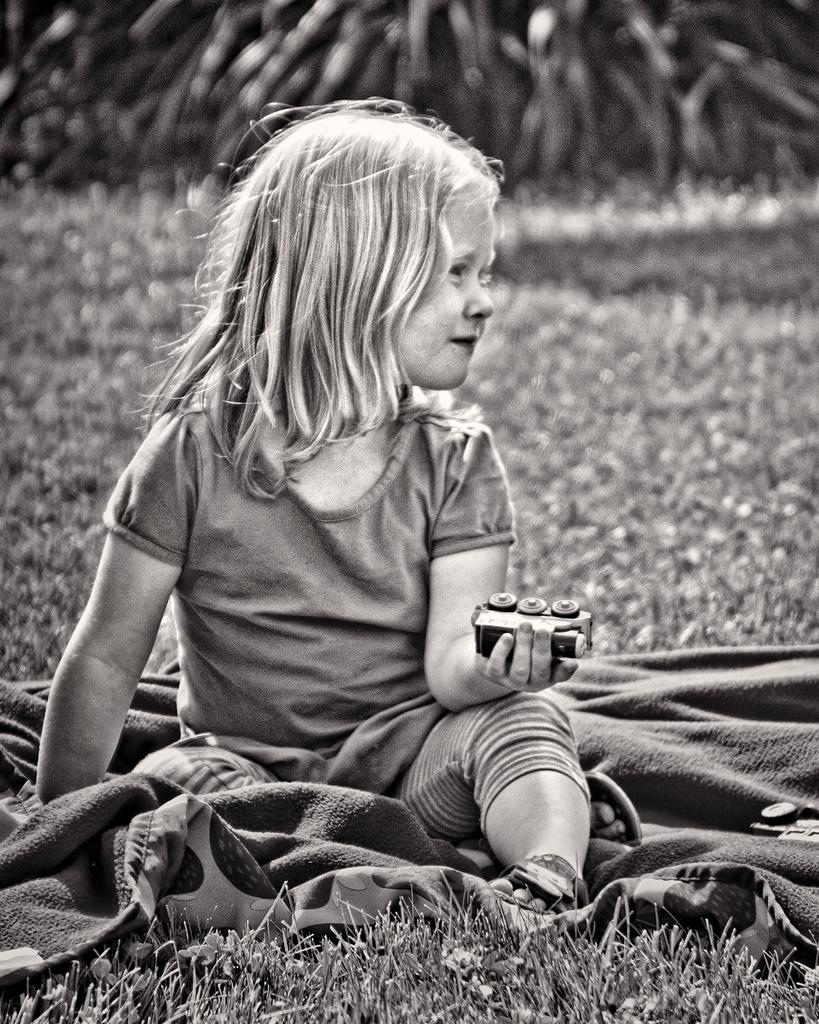What is the color scheme of the image? The image is black and white. Who is present in the image? There is a girl in the image. What is the girl sitting on? The girl is sitting on a cloth. Where is the cloth located? The cloth is on grass. Can you describe the background of the image? There is another cloth visible behind the girl. What type of robin can be seen sitting on the whip in the image? There is no robin or whip present in the image. What kind of loaf is the girl holding in the image? There is no loaf visible in the image. 